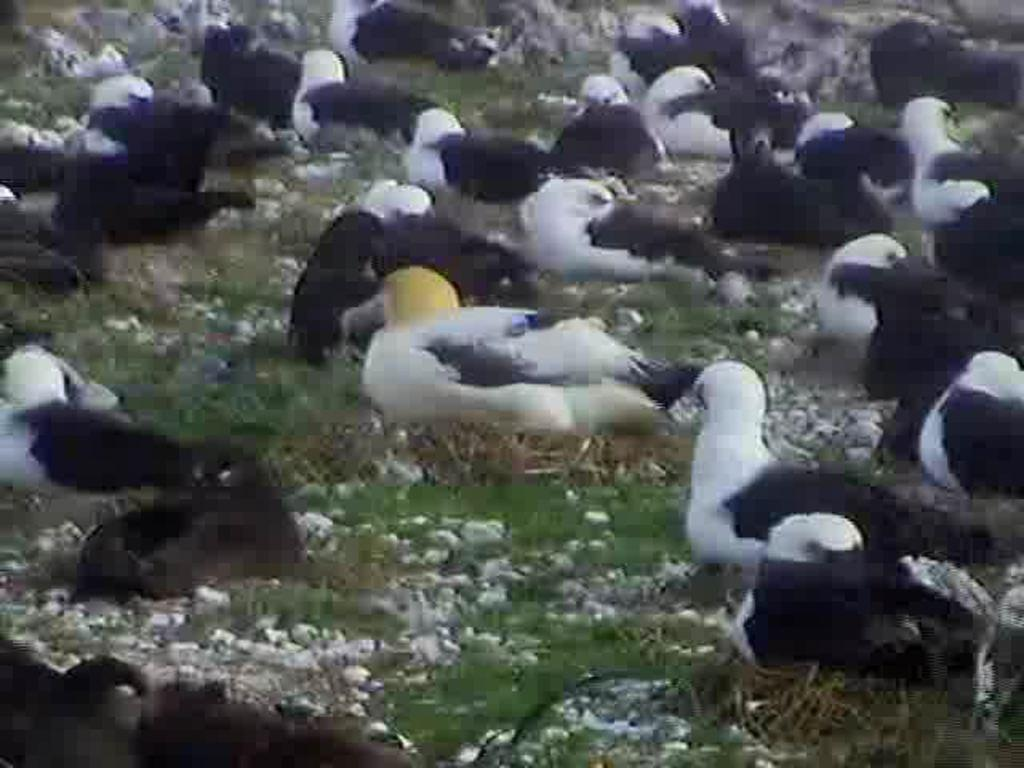What is located in the center of the image? There are birds in the center of the image. What is the surface on which the birds are standing? The birds are on the grass. Can you describe any other elements in the image besides the birds? Yes, there are objects visible in the image. What type of vegetable is being harvested in the image? There is no vegetable being harvested in the image; it features birds on the grass. How many rings can be seen on the fingers of the birds in the image? There are no rings visible on the birds in the image, as birds do not wear rings. 